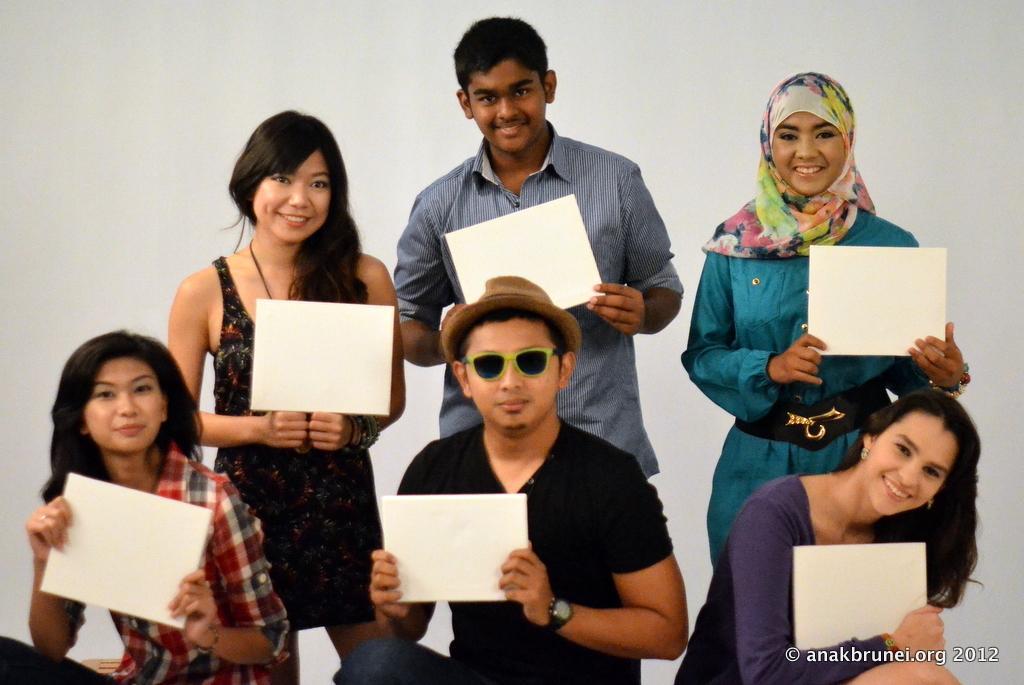Describe this image in one or two sentences. In this image, we can see persons on the white background. These persons are wearing clothes and holding placards with their hands. 